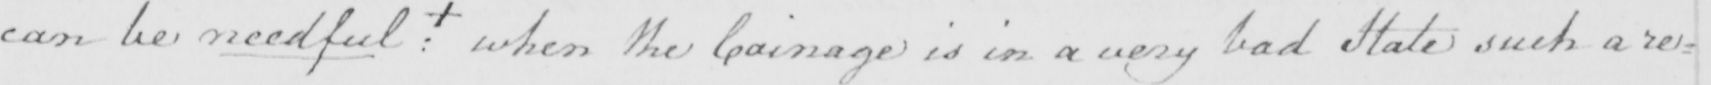Please provide the text content of this handwritten line. can be needful  :  +  when the Coinage is in a very bad State such a re= 